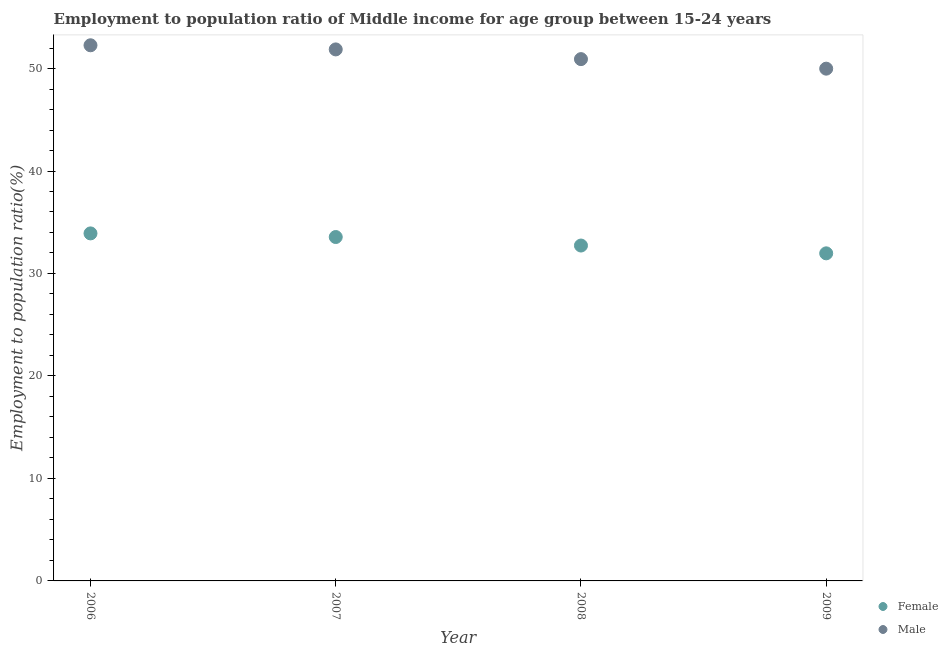How many different coloured dotlines are there?
Keep it short and to the point. 2. Is the number of dotlines equal to the number of legend labels?
Your answer should be compact. Yes. What is the employment to population ratio(female) in 2006?
Make the answer very short. 33.91. Across all years, what is the maximum employment to population ratio(male)?
Offer a very short reply. 52.27. Across all years, what is the minimum employment to population ratio(male)?
Provide a short and direct response. 49.99. In which year was the employment to population ratio(male) maximum?
Offer a terse response. 2006. In which year was the employment to population ratio(male) minimum?
Your answer should be very brief. 2009. What is the total employment to population ratio(female) in the graph?
Provide a short and direct response. 132.16. What is the difference between the employment to population ratio(female) in 2007 and that in 2009?
Provide a succinct answer. 1.59. What is the difference between the employment to population ratio(male) in 2009 and the employment to population ratio(female) in 2008?
Keep it short and to the point. 17.26. What is the average employment to population ratio(male) per year?
Ensure brevity in your answer.  51.26. In the year 2009, what is the difference between the employment to population ratio(male) and employment to population ratio(female)?
Provide a succinct answer. 18.02. In how many years, is the employment to population ratio(male) greater than 14 %?
Keep it short and to the point. 4. What is the ratio of the employment to population ratio(male) in 2006 to that in 2007?
Make the answer very short. 1.01. Is the difference between the employment to population ratio(female) in 2006 and 2009 greater than the difference between the employment to population ratio(male) in 2006 and 2009?
Keep it short and to the point. No. What is the difference between the highest and the second highest employment to population ratio(male)?
Keep it short and to the point. 0.4. What is the difference between the highest and the lowest employment to population ratio(male)?
Offer a very short reply. 2.28. In how many years, is the employment to population ratio(male) greater than the average employment to population ratio(male) taken over all years?
Your answer should be very brief. 2. Is the sum of the employment to population ratio(male) in 2006 and 2007 greater than the maximum employment to population ratio(female) across all years?
Your response must be concise. Yes. Is the employment to population ratio(female) strictly less than the employment to population ratio(male) over the years?
Give a very brief answer. Yes. How many years are there in the graph?
Your response must be concise. 4. What is the difference between two consecutive major ticks on the Y-axis?
Provide a short and direct response. 10. Are the values on the major ticks of Y-axis written in scientific E-notation?
Your answer should be very brief. No. Where does the legend appear in the graph?
Give a very brief answer. Bottom right. What is the title of the graph?
Make the answer very short. Employment to population ratio of Middle income for age group between 15-24 years. What is the label or title of the Y-axis?
Provide a succinct answer. Employment to population ratio(%). What is the Employment to population ratio(%) in Female in 2006?
Provide a succinct answer. 33.91. What is the Employment to population ratio(%) in Male in 2006?
Offer a very short reply. 52.27. What is the Employment to population ratio(%) in Female in 2007?
Keep it short and to the point. 33.56. What is the Employment to population ratio(%) in Male in 2007?
Your answer should be compact. 51.87. What is the Employment to population ratio(%) in Female in 2008?
Your answer should be compact. 32.73. What is the Employment to population ratio(%) of Male in 2008?
Give a very brief answer. 50.92. What is the Employment to population ratio(%) in Female in 2009?
Your answer should be very brief. 31.97. What is the Employment to population ratio(%) of Male in 2009?
Ensure brevity in your answer.  49.99. Across all years, what is the maximum Employment to population ratio(%) in Female?
Your answer should be compact. 33.91. Across all years, what is the maximum Employment to population ratio(%) in Male?
Provide a short and direct response. 52.27. Across all years, what is the minimum Employment to population ratio(%) in Female?
Your response must be concise. 31.97. Across all years, what is the minimum Employment to population ratio(%) of Male?
Your response must be concise. 49.99. What is the total Employment to population ratio(%) in Female in the graph?
Your answer should be compact. 132.16. What is the total Employment to population ratio(%) in Male in the graph?
Ensure brevity in your answer.  205.04. What is the difference between the Employment to population ratio(%) of Female in 2006 and that in 2007?
Offer a very short reply. 0.35. What is the difference between the Employment to population ratio(%) of Male in 2006 and that in 2007?
Offer a very short reply. 0.4. What is the difference between the Employment to population ratio(%) of Female in 2006 and that in 2008?
Offer a very short reply. 1.18. What is the difference between the Employment to population ratio(%) of Male in 2006 and that in 2008?
Your answer should be very brief. 1.35. What is the difference between the Employment to population ratio(%) of Female in 2006 and that in 2009?
Your answer should be compact. 1.95. What is the difference between the Employment to population ratio(%) in Male in 2006 and that in 2009?
Your answer should be compact. 2.28. What is the difference between the Employment to population ratio(%) of Female in 2007 and that in 2008?
Provide a short and direct response. 0.83. What is the difference between the Employment to population ratio(%) of Male in 2007 and that in 2008?
Make the answer very short. 0.95. What is the difference between the Employment to population ratio(%) of Female in 2007 and that in 2009?
Offer a terse response. 1.59. What is the difference between the Employment to population ratio(%) of Male in 2007 and that in 2009?
Provide a short and direct response. 1.88. What is the difference between the Employment to population ratio(%) in Female in 2008 and that in 2009?
Provide a short and direct response. 0.76. What is the difference between the Employment to population ratio(%) of Male in 2008 and that in 2009?
Ensure brevity in your answer.  0.93. What is the difference between the Employment to population ratio(%) of Female in 2006 and the Employment to population ratio(%) of Male in 2007?
Your answer should be very brief. -17.95. What is the difference between the Employment to population ratio(%) of Female in 2006 and the Employment to population ratio(%) of Male in 2008?
Your answer should be compact. -17.01. What is the difference between the Employment to population ratio(%) of Female in 2006 and the Employment to population ratio(%) of Male in 2009?
Your answer should be compact. -16.08. What is the difference between the Employment to population ratio(%) of Female in 2007 and the Employment to population ratio(%) of Male in 2008?
Your answer should be compact. -17.36. What is the difference between the Employment to population ratio(%) in Female in 2007 and the Employment to population ratio(%) in Male in 2009?
Offer a very short reply. -16.43. What is the difference between the Employment to population ratio(%) in Female in 2008 and the Employment to population ratio(%) in Male in 2009?
Make the answer very short. -17.26. What is the average Employment to population ratio(%) in Female per year?
Your answer should be compact. 33.04. What is the average Employment to population ratio(%) of Male per year?
Offer a very short reply. 51.26. In the year 2006, what is the difference between the Employment to population ratio(%) of Female and Employment to population ratio(%) of Male?
Ensure brevity in your answer.  -18.36. In the year 2007, what is the difference between the Employment to population ratio(%) in Female and Employment to population ratio(%) in Male?
Offer a very short reply. -18.31. In the year 2008, what is the difference between the Employment to population ratio(%) in Female and Employment to population ratio(%) in Male?
Make the answer very short. -18.19. In the year 2009, what is the difference between the Employment to population ratio(%) in Female and Employment to population ratio(%) in Male?
Make the answer very short. -18.02. What is the ratio of the Employment to population ratio(%) in Female in 2006 to that in 2007?
Make the answer very short. 1.01. What is the ratio of the Employment to population ratio(%) of Female in 2006 to that in 2008?
Provide a succinct answer. 1.04. What is the ratio of the Employment to population ratio(%) in Male in 2006 to that in 2008?
Provide a succinct answer. 1.03. What is the ratio of the Employment to population ratio(%) in Female in 2006 to that in 2009?
Your answer should be very brief. 1.06. What is the ratio of the Employment to population ratio(%) of Male in 2006 to that in 2009?
Your answer should be compact. 1.05. What is the ratio of the Employment to population ratio(%) of Female in 2007 to that in 2008?
Provide a succinct answer. 1.03. What is the ratio of the Employment to population ratio(%) of Male in 2007 to that in 2008?
Ensure brevity in your answer.  1.02. What is the ratio of the Employment to population ratio(%) of Female in 2007 to that in 2009?
Provide a succinct answer. 1.05. What is the ratio of the Employment to population ratio(%) of Male in 2007 to that in 2009?
Your answer should be very brief. 1.04. What is the ratio of the Employment to population ratio(%) in Female in 2008 to that in 2009?
Your answer should be very brief. 1.02. What is the ratio of the Employment to population ratio(%) of Male in 2008 to that in 2009?
Offer a terse response. 1.02. What is the difference between the highest and the second highest Employment to population ratio(%) in Female?
Offer a terse response. 0.35. What is the difference between the highest and the second highest Employment to population ratio(%) of Male?
Keep it short and to the point. 0.4. What is the difference between the highest and the lowest Employment to population ratio(%) of Female?
Ensure brevity in your answer.  1.95. What is the difference between the highest and the lowest Employment to population ratio(%) of Male?
Provide a short and direct response. 2.28. 